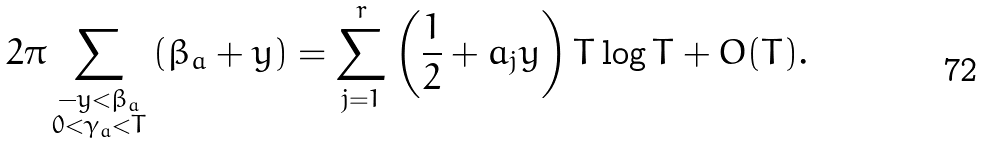Convert formula to latex. <formula><loc_0><loc_0><loc_500><loc_500>2 \pi \sum _ { \substack { - y < \beta _ { a } \\ 0 < \gamma _ { a } < T } } \left ( \beta _ { a } + y \right ) = \sum _ { j = 1 } ^ { r } \left ( \frac { 1 } { 2 } + a _ { j } y \right ) T \log T + O ( T ) .</formula> 